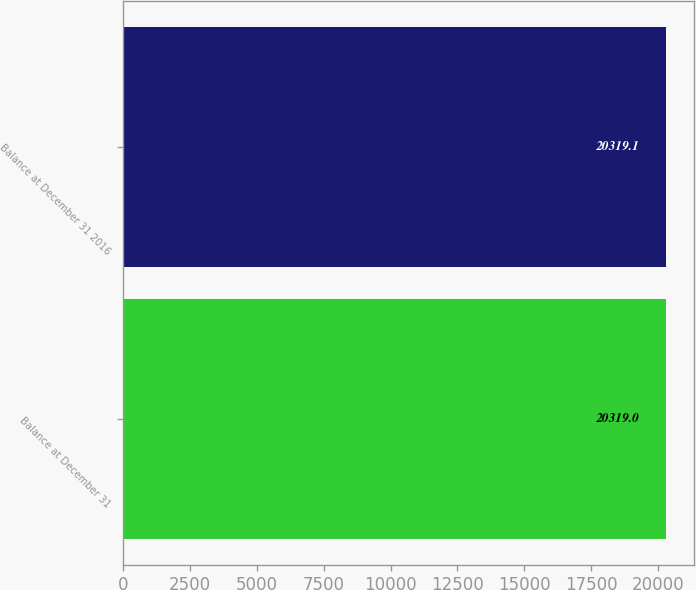Convert chart to OTSL. <chart><loc_0><loc_0><loc_500><loc_500><bar_chart><fcel>Balance at December 31<fcel>Balance at December 31 2016<nl><fcel>20319<fcel>20319.1<nl></chart> 